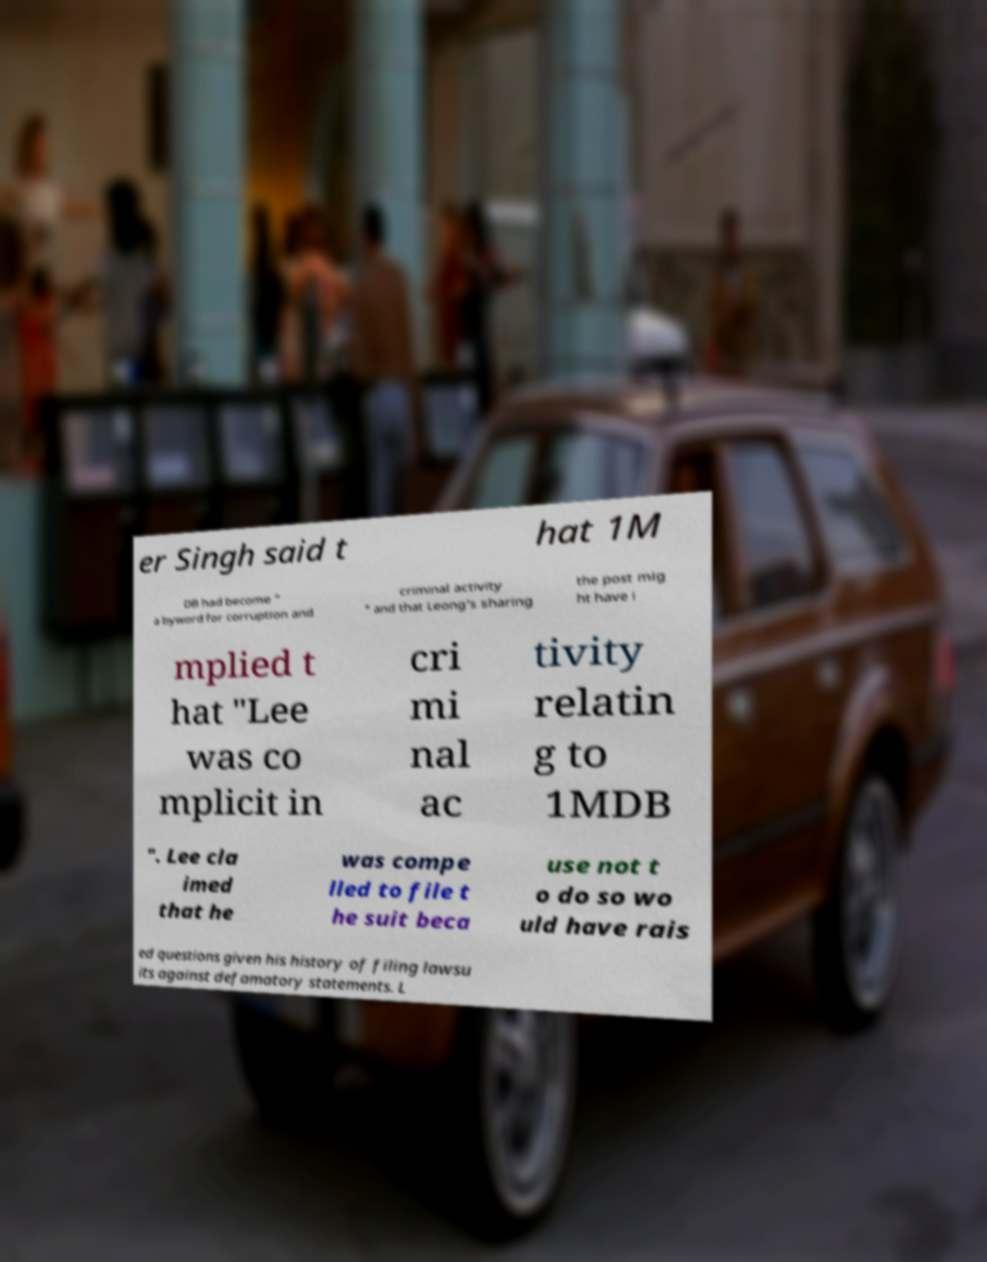Can you accurately transcribe the text from the provided image for me? er Singh said t hat 1M DB had become " a byword for corruption and criminal activity " and that Leong's sharing the post mig ht have i mplied t hat "Lee was co mplicit in cri mi nal ac tivity relatin g to 1MDB ". Lee cla imed that he was compe lled to file t he suit beca use not t o do so wo uld have rais ed questions given his history of filing lawsu its against defamatory statements. L 